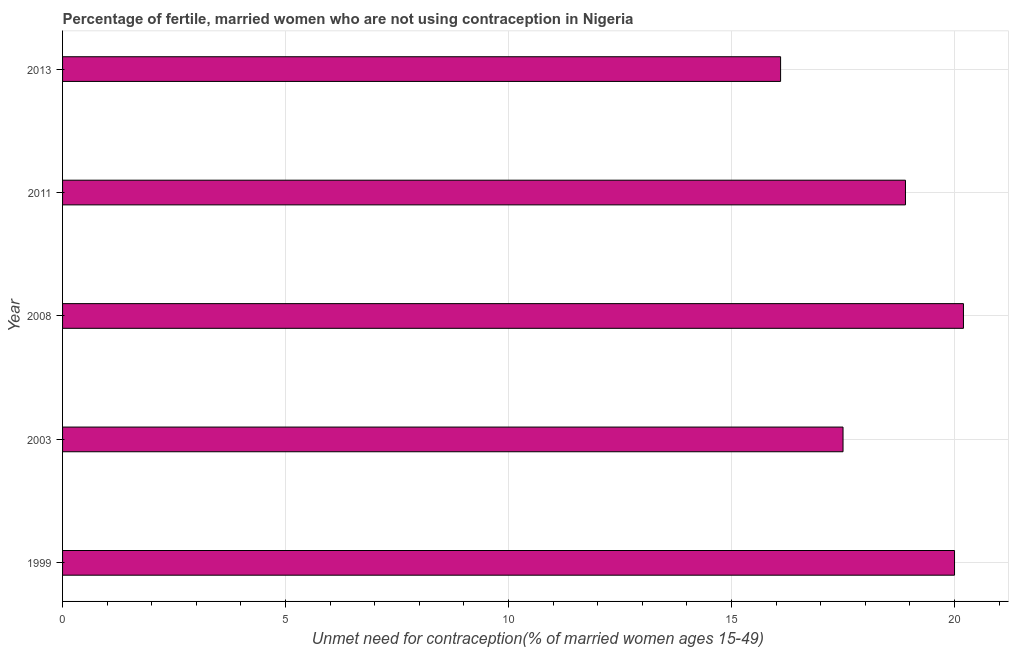What is the title of the graph?
Make the answer very short. Percentage of fertile, married women who are not using contraception in Nigeria. What is the label or title of the X-axis?
Offer a terse response.  Unmet need for contraception(% of married women ages 15-49). What is the label or title of the Y-axis?
Your answer should be compact. Year. Across all years, what is the maximum number of married women who are not using contraception?
Give a very brief answer. 20.2. In which year was the number of married women who are not using contraception minimum?
Ensure brevity in your answer.  2013. What is the sum of the number of married women who are not using contraception?
Offer a very short reply. 92.7. What is the difference between the number of married women who are not using contraception in 2003 and 2008?
Offer a very short reply. -2.7. What is the average number of married women who are not using contraception per year?
Make the answer very short. 18.54. In how many years, is the number of married women who are not using contraception greater than 9 %?
Provide a succinct answer. 5. What is the ratio of the number of married women who are not using contraception in 1999 to that in 2003?
Offer a very short reply. 1.14. Is the number of married women who are not using contraception in 2003 less than that in 2011?
Your answer should be very brief. Yes. Is the difference between the number of married women who are not using contraception in 2003 and 2008 greater than the difference between any two years?
Keep it short and to the point. No. What is the difference between the highest and the second highest number of married women who are not using contraception?
Keep it short and to the point. 0.2. Is the sum of the number of married women who are not using contraception in 1999 and 2011 greater than the maximum number of married women who are not using contraception across all years?
Your response must be concise. Yes. In how many years, is the number of married women who are not using contraception greater than the average number of married women who are not using contraception taken over all years?
Your answer should be compact. 3. How many years are there in the graph?
Provide a short and direct response. 5. What is the difference between two consecutive major ticks on the X-axis?
Your answer should be very brief. 5. What is the  Unmet need for contraception(% of married women ages 15-49) of 1999?
Your answer should be compact. 20. What is the  Unmet need for contraception(% of married women ages 15-49) of 2003?
Your answer should be compact. 17.5. What is the  Unmet need for contraception(% of married women ages 15-49) of 2008?
Provide a succinct answer. 20.2. What is the  Unmet need for contraception(% of married women ages 15-49) in 2011?
Ensure brevity in your answer.  18.9. What is the difference between the  Unmet need for contraception(% of married women ages 15-49) in 1999 and 2003?
Offer a terse response. 2.5. What is the difference between the  Unmet need for contraception(% of married women ages 15-49) in 2003 and 2008?
Offer a terse response. -2.7. What is the difference between the  Unmet need for contraception(% of married women ages 15-49) in 2003 and 2011?
Offer a terse response. -1.4. What is the difference between the  Unmet need for contraception(% of married women ages 15-49) in 2008 and 2013?
Keep it short and to the point. 4.1. What is the ratio of the  Unmet need for contraception(% of married women ages 15-49) in 1999 to that in 2003?
Offer a terse response. 1.14. What is the ratio of the  Unmet need for contraception(% of married women ages 15-49) in 1999 to that in 2011?
Offer a very short reply. 1.06. What is the ratio of the  Unmet need for contraception(% of married women ages 15-49) in 1999 to that in 2013?
Make the answer very short. 1.24. What is the ratio of the  Unmet need for contraception(% of married women ages 15-49) in 2003 to that in 2008?
Offer a very short reply. 0.87. What is the ratio of the  Unmet need for contraception(% of married women ages 15-49) in 2003 to that in 2011?
Your answer should be very brief. 0.93. What is the ratio of the  Unmet need for contraception(% of married women ages 15-49) in 2003 to that in 2013?
Provide a short and direct response. 1.09. What is the ratio of the  Unmet need for contraception(% of married women ages 15-49) in 2008 to that in 2011?
Your answer should be very brief. 1.07. What is the ratio of the  Unmet need for contraception(% of married women ages 15-49) in 2008 to that in 2013?
Make the answer very short. 1.25. What is the ratio of the  Unmet need for contraception(% of married women ages 15-49) in 2011 to that in 2013?
Your response must be concise. 1.17. 